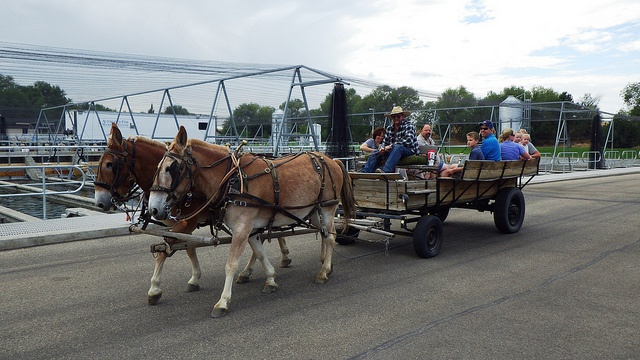Describe the objects in this image and their specific colors. I can see horse in lightgray, black, gray, and maroon tones, horse in lightgray, black, gray, maroon, and darkgray tones, horse in lightgray, black, maroon, and gray tones, people in lightgray, black, navy, gray, and darkblue tones, and bench in lightgray, black, and gray tones in this image. 